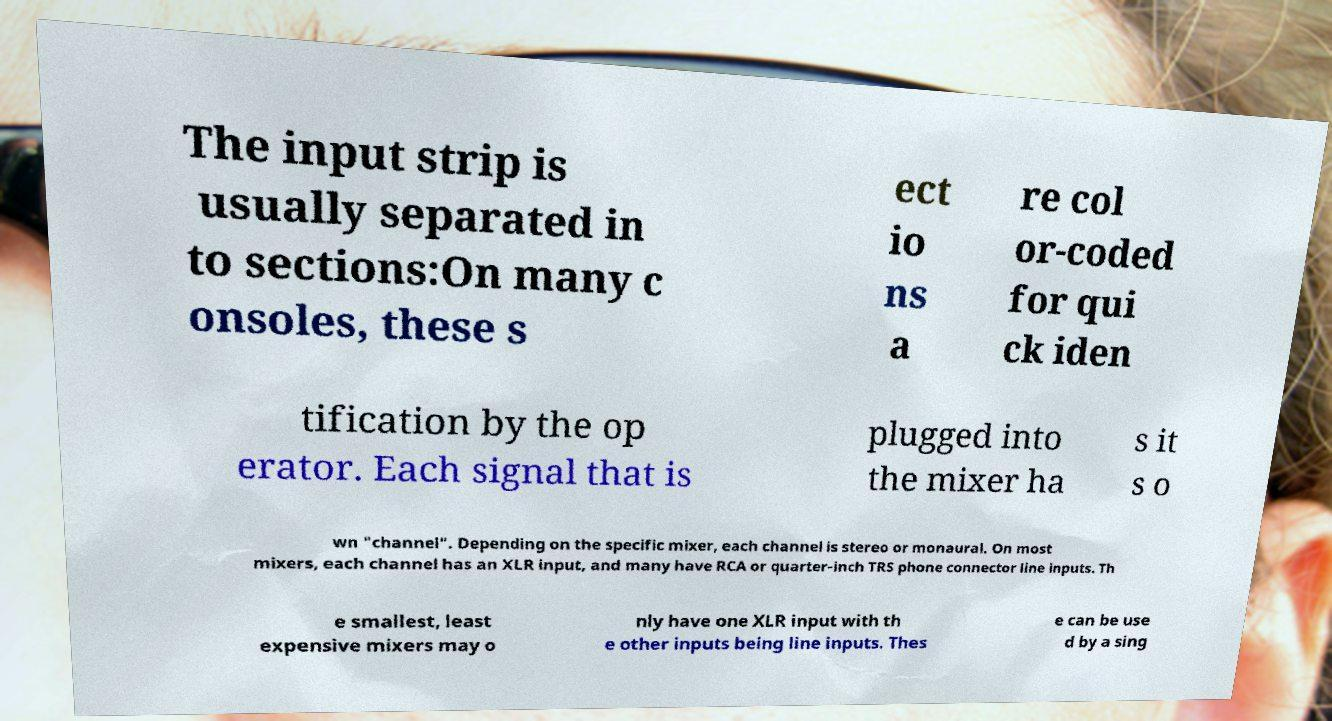Could you extract and type out the text from this image? The input strip is usually separated in to sections:On many c onsoles, these s ect io ns a re col or-coded for qui ck iden tification by the op erator. Each signal that is plugged into the mixer ha s it s o wn "channel". Depending on the specific mixer, each channel is stereo or monaural. On most mixers, each channel has an XLR input, and many have RCA or quarter-inch TRS phone connector line inputs. Th e smallest, least expensive mixers may o nly have one XLR input with th e other inputs being line inputs. Thes e can be use d by a sing 